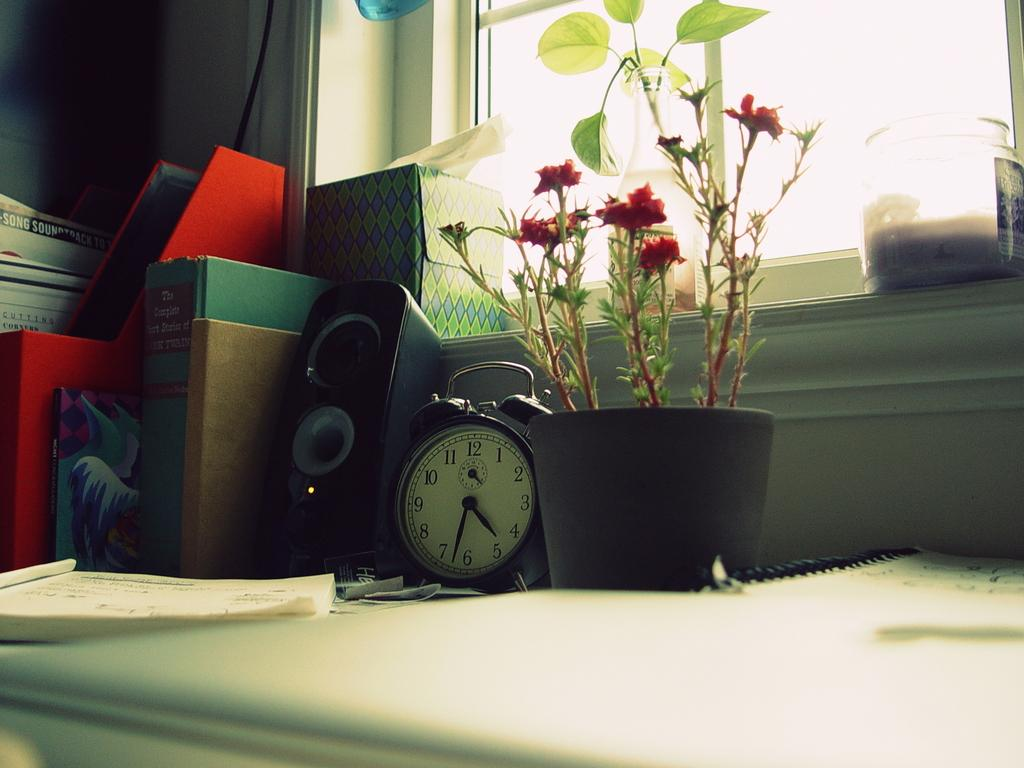Provide a one-sentence caption for the provided image. A clock by a plant shows a time of a bout 4:32. 